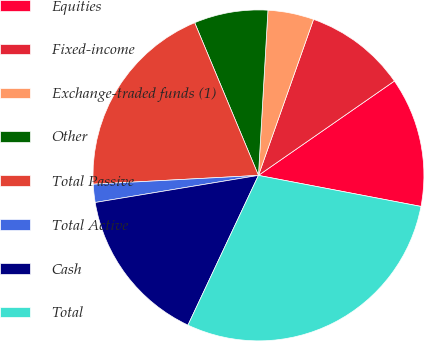<chart> <loc_0><loc_0><loc_500><loc_500><pie_chart><fcel>Equities<fcel>Fixed-income<fcel>Exchange-traded funds (1)<fcel>Other<fcel>Total Passive<fcel>Total Active<fcel>Cash<fcel>Total<nl><fcel>12.66%<fcel>9.94%<fcel>4.49%<fcel>7.21%<fcel>19.55%<fcel>1.77%<fcel>15.38%<fcel>29.0%<nl></chart> 